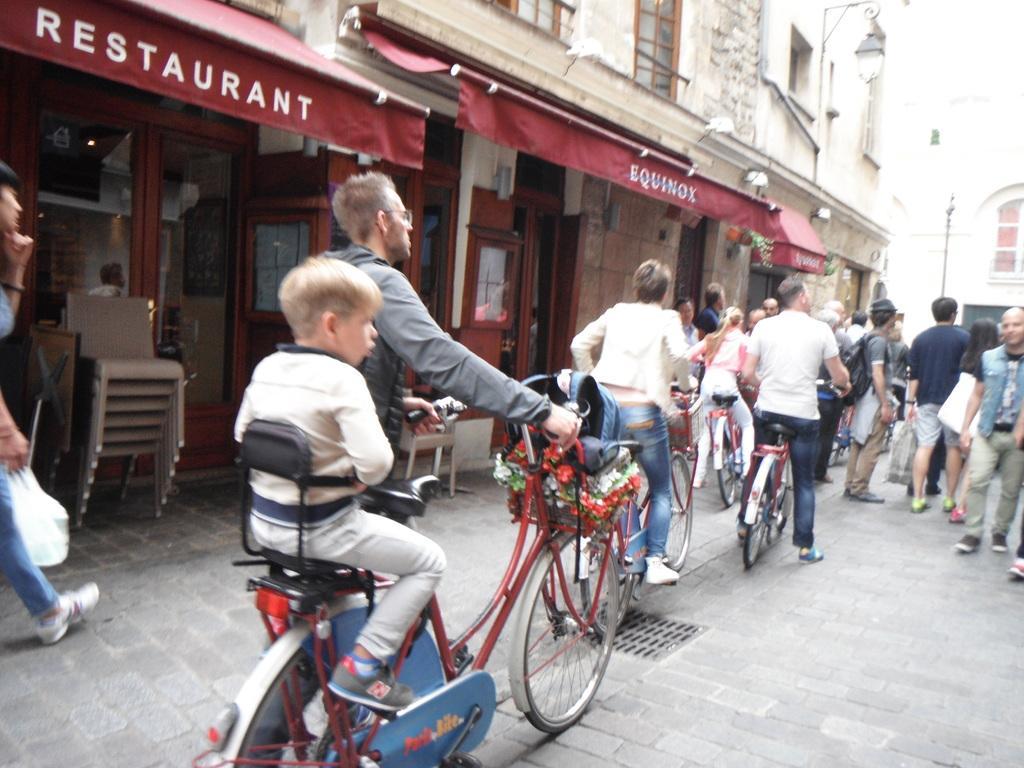In one or two sentences, can you explain what this image depicts? This is the image of the city where a boy is sitting in the bicycle seat and the man is holding the bicycle and at the right side of these 2 persons there are group of people who are riding bicycles and they are standing and at the back ground there is a big building , and a restaurant and there are chairs too. 